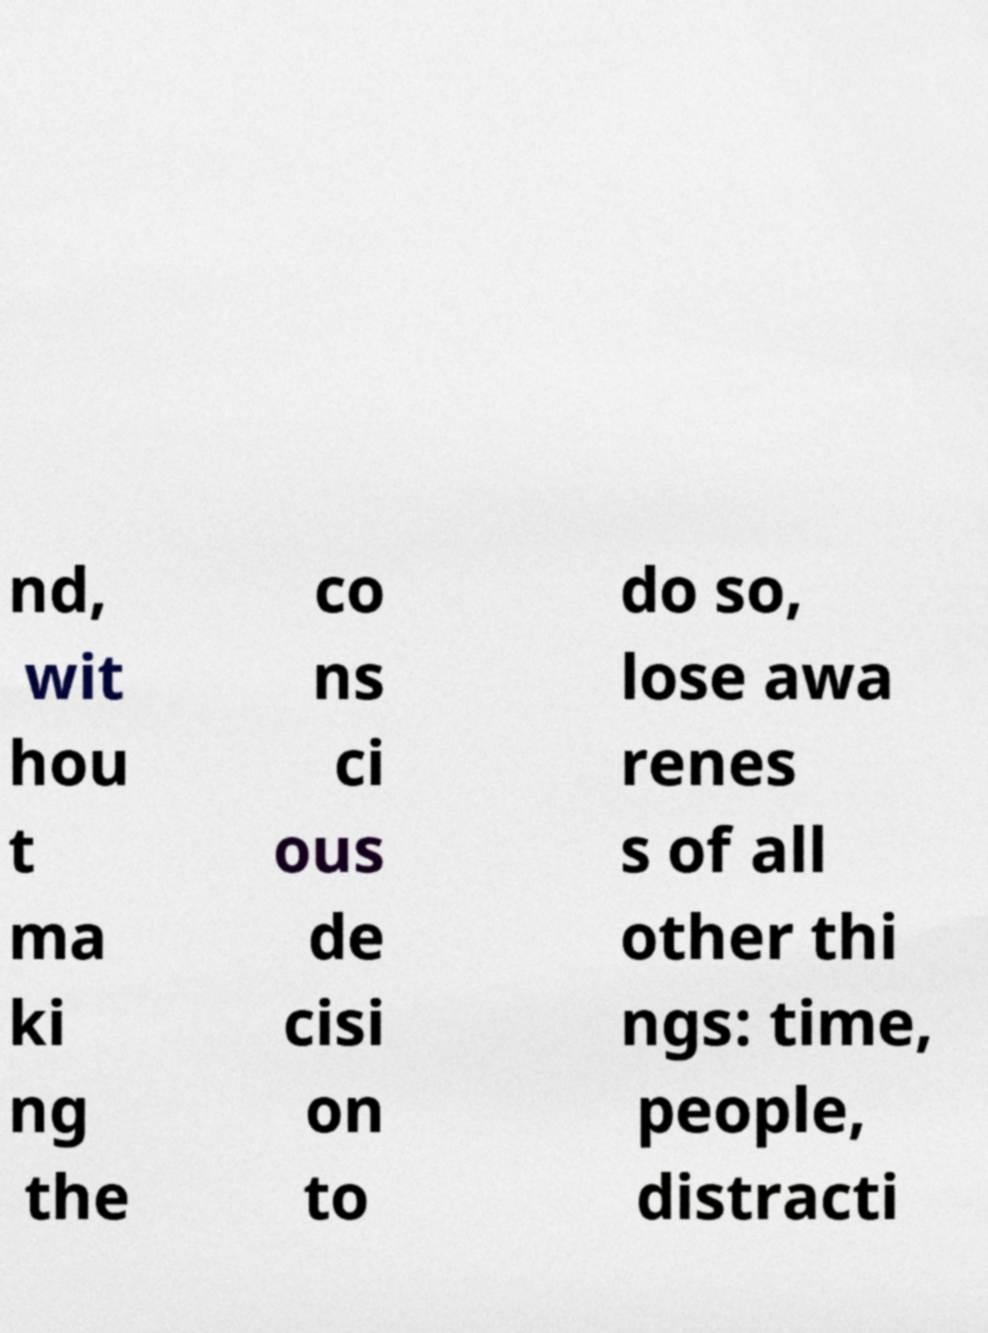Can you read and provide the text displayed in the image?This photo seems to have some interesting text. Can you extract and type it out for me? nd, wit hou t ma ki ng the co ns ci ous de cisi on to do so, lose awa renes s of all other thi ngs: time, people, distracti 